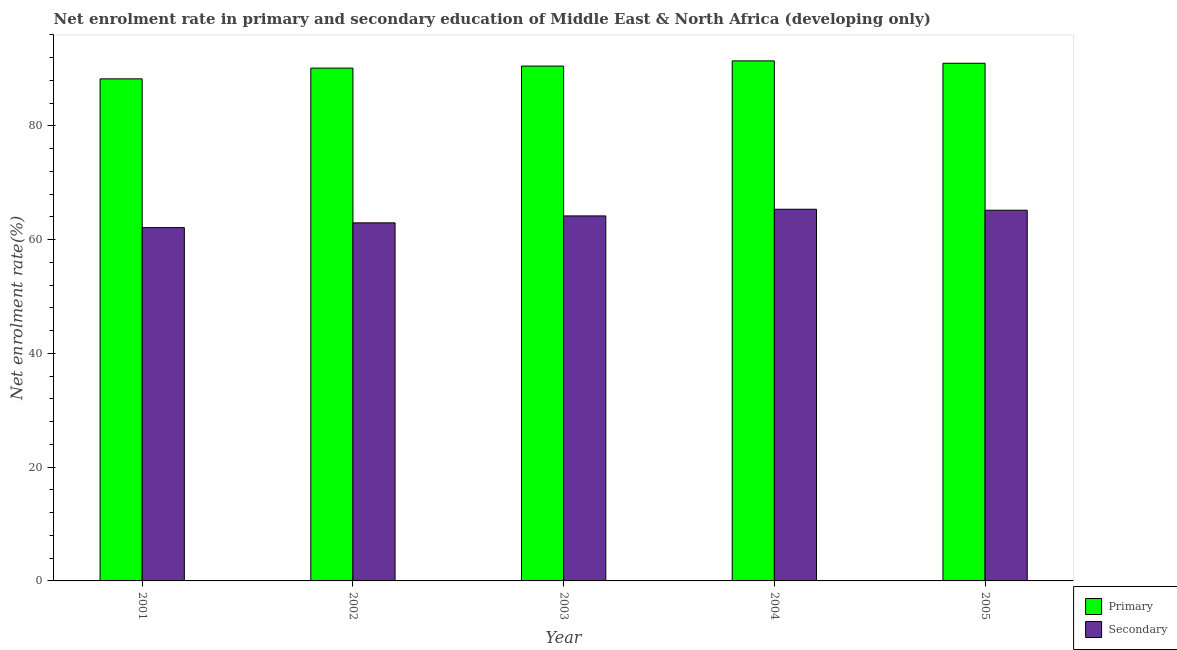How many different coloured bars are there?
Provide a succinct answer. 2. How many groups of bars are there?
Keep it short and to the point. 5. Are the number of bars on each tick of the X-axis equal?
Offer a terse response. Yes. How many bars are there on the 3rd tick from the left?
Make the answer very short. 2. What is the label of the 4th group of bars from the left?
Offer a terse response. 2004. In how many cases, is the number of bars for a given year not equal to the number of legend labels?
Your answer should be compact. 0. What is the enrollment rate in primary education in 2004?
Offer a very short reply. 91.43. Across all years, what is the maximum enrollment rate in primary education?
Offer a terse response. 91.43. Across all years, what is the minimum enrollment rate in primary education?
Give a very brief answer. 88.27. What is the total enrollment rate in primary education in the graph?
Your answer should be very brief. 451.39. What is the difference between the enrollment rate in primary education in 2001 and that in 2003?
Ensure brevity in your answer.  -2.25. What is the difference between the enrollment rate in secondary education in 2005 and the enrollment rate in primary education in 2001?
Provide a succinct answer. 3.05. What is the average enrollment rate in secondary education per year?
Your answer should be compact. 63.95. What is the ratio of the enrollment rate in secondary education in 2001 to that in 2004?
Keep it short and to the point. 0.95. What is the difference between the highest and the second highest enrollment rate in secondary education?
Give a very brief answer. 0.17. What is the difference between the highest and the lowest enrollment rate in secondary education?
Offer a very short reply. 3.22. Is the sum of the enrollment rate in secondary education in 2004 and 2005 greater than the maximum enrollment rate in primary education across all years?
Give a very brief answer. Yes. What does the 2nd bar from the left in 2003 represents?
Ensure brevity in your answer.  Secondary. What does the 2nd bar from the right in 2001 represents?
Your response must be concise. Primary. How many years are there in the graph?
Ensure brevity in your answer.  5. What is the difference between two consecutive major ticks on the Y-axis?
Offer a very short reply. 20. Are the values on the major ticks of Y-axis written in scientific E-notation?
Your response must be concise. No. Where does the legend appear in the graph?
Provide a succinct answer. Bottom right. What is the title of the graph?
Your response must be concise. Net enrolment rate in primary and secondary education of Middle East & North Africa (developing only). What is the label or title of the Y-axis?
Your answer should be very brief. Net enrolment rate(%). What is the Net enrolment rate(%) in Primary in 2001?
Ensure brevity in your answer.  88.27. What is the Net enrolment rate(%) in Secondary in 2001?
Offer a terse response. 62.12. What is the Net enrolment rate(%) of Primary in 2002?
Keep it short and to the point. 90.16. What is the Net enrolment rate(%) in Secondary in 2002?
Provide a succinct answer. 62.95. What is the Net enrolment rate(%) in Primary in 2003?
Provide a succinct answer. 90.52. What is the Net enrolment rate(%) of Secondary in 2003?
Ensure brevity in your answer.  64.17. What is the Net enrolment rate(%) in Primary in 2004?
Offer a very short reply. 91.43. What is the Net enrolment rate(%) of Secondary in 2004?
Your answer should be compact. 65.34. What is the Net enrolment rate(%) of Primary in 2005?
Your answer should be very brief. 91.01. What is the Net enrolment rate(%) in Secondary in 2005?
Make the answer very short. 65.17. Across all years, what is the maximum Net enrolment rate(%) in Primary?
Your answer should be compact. 91.43. Across all years, what is the maximum Net enrolment rate(%) in Secondary?
Keep it short and to the point. 65.34. Across all years, what is the minimum Net enrolment rate(%) in Primary?
Offer a terse response. 88.27. Across all years, what is the minimum Net enrolment rate(%) of Secondary?
Provide a short and direct response. 62.12. What is the total Net enrolment rate(%) of Primary in the graph?
Your answer should be compact. 451.39. What is the total Net enrolment rate(%) in Secondary in the graph?
Keep it short and to the point. 319.76. What is the difference between the Net enrolment rate(%) of Primary in 2001 and that in 2002?
Give a very brief answer. -1.89. What is the difference between the Net enrolment rate(%) of Secondary in 2001 and that in 2002?
Give a very brief answer. -0.83. What is the difference between the Net enrolment rate(%) of Primary in 2001 and that in 2003?
Make the answer very short. -2.25. What is the difference between the Net enrolment rate(%) of Secondary in 2001 and that in 2003?
Make the answer very short. -2.05. What is the difference between the Net enrolment rate(%) in Primary in 2001 and that in 2004?
Keep it short and to the point. -3.16. What is the difference between the Net enrolment rate(%) in Secondary in 2001 and that in 2004?
Keep it short and to the point. -3.22. What is the difference between the Net enrolment rate(%) in Primary in 2001 and that in 2005?
Offer a terse response. -2.74. What is the difference between the Net enrolment rate(%) of Secondary in 2001 and that in 2005?
Your answer should be very brief. -3.05. What is the difference between the Net enrolment rate(%) of Primary in 2002 and that in 2003?
Make the answer very short. -0.36. What is the difference between the Net enrolment rate(%) of Secondary in 2002 and that in 2003?
Your answer should be very brief. -1.22. What is the difference between the Net enrolment rate(%) of Primary in 2002 and that in 2004?
Your answer should be very brief. -1.27. What is the difference between the Net enrolment rate(%) in Secondary in 2002 and that in 2004?
Offer a very short reply. -2.39. What is the difference between the Net enrolment rate(%) in Primary in 2002 and that in 2005?
Offer a terse response. -0.85. What is the difference between the Net enrolment rate(%) of Secondary in 2002 and that in 2005?
Offer a very short reply. -2.22. What is the difference between the Net enrolment rate(%) of Primary in 2003 and that in 2004?
Ensure brevity in your answer.  -0.91. What is the difference between the Net enrolment rate(%) of Secondary in 2003 and that in 2004?
Provide a short and direct response. -1.17. What is the difference between the Net enrolment rate(%) in Primary in 2003 and that in 2005?
Give a very brief answer. -0.49. What is the difference between the Net enrolment rate(%) in Secondary in 2003 and that in 2005?
Give a very brief answer. -1. What is the difference between the Net enrolment rate(%) in Primary in 2004 and that in 2005?
Keep it short and to the point. 0.42. What is the difference between the Net enrolment rate(%) of Secondary in 2004 and that in 2005?
Make the answer very short. 0.17. What is the difference between the Net enrolment rate(%) in Primary in 2001 and the Net enrolment rate(%) in Secondary in 2002?
Your answer should be very brief. 25.32. What is the difference between the Net enrolment rate(%) in Primary in 2001 and the Net enrolment rate(%) in Secondary in 2003?
Give a very brief answer. 24.1. What is the difference between the Net enrolment rate(%) of Primary in 2001 and the Net enrolment rate(%) of Secondary in 2004?
Offer a very short reply. 22.93. What is the difference between the Net enrolment rate(%) in Primary in 2001 and the Net enrolment rate(%) in Secondary in 2005?
Your answer should be compact. 23.1. What is the difference between the Net enrolment rate(%) of Primary in 2002 and the Net enrolment rate(%) of Secondary in 2003?
Make the answer very short. 25.99. What is the difference between the Net enrolment rate(%) of Primary in 2002 and the Net enrolment rate(%) of Secondary in 2004?
Provide a short and direct response. 24.82. What is the difference between the Net enrolment rate(%) in Primary in 2002 and the Net enrolment rate(%) in Secondary in 2005?
Offer a very short reply. 24.99. What is the difference between the Net enrolment rate(%) of Primary in 2003 and the Net enrolment rate(%) of Secondary in 2004?
Make the answer very short. 25.17. What is the difference between the Net enrolment rate(%) of Primary in 2003 and the Net enrolment rate(%) of Secondary in 2005?
Give a very brief answer. 25.35. What is the difference between the Net enrolment rate(%) of Primary in 2004 and the Net enrolment rate(%) of Secondary in 2005?
Your answer should be compact. 26.26. What is the average Net enrolment rate(%) in Primary per year?
Ensure brevity in your answer.  90.28. What is the average Net enrolment rate(%) in Secondary per year?
Your response must be concise. 63.95. In the year 2001, what is the difference between the Net enrolment rate(%) of Primary and Net enrolment rate(%) of Secondary?
Your answer should be very brief. 26.15. In the year 2002, what is the difference between the Net enrolment rate(%) in Primary and Net enrolment rate(%) in Secondary?
Provide a short and direct response. 27.21. In the year 2003, what is the difference between the Net enrolment rate(%) in Primary and Net enrolment rate(%) in Secondary?
Ensure brevity in your answer.  26.35. In the year 2004, what is the difference between the Net enrolment rate(%) in Primary and Net enrolment rate(%) in Secondary?
Your answer should be very brief. 26.09. In the year 2005, what is the difference between the Net enrolment rate(%) in Primary and Net enrolment rate(%) in Secondary?
Ensure brevity in your answer.  25.84. What is the ratio of the Net enrolment rate(%) of Primary in 2001 to that in 2002?
Provide a succinct answer. 0.98. What is the ratio of the Net enrolment rate(%) in Secondary in 2001 to that in 2002?
Offer a very short reply. 0.99. What is the ratio of the Net enrolment rate(%) in Primary in 2001 to that in 2003?
Your answer should be compact. 0.98. What is the ratio of the Net enrolment rate(%) in Secondary in 2001 to that in 2003?
Provide a short and direct response. 0.97. What is the ratio of the Net enrolment rate(%) in Primary in 2001 to that in 2004?
Your answer should be compact. 0.97. What is the ratio of the Net enrolment rate(%) of Secondary in 2001 to that in 2004?
Your response must be concise. 0.95. What is the ratio of the Net enrolment rate(%) of Primary in 2001 to that in 2005?
Give a very brief answer. 0.97. What is the ratio of the Net enrolment rate(%) in Secondary in 2001 to that in 2005?
Give a very brief answer. 0.95. What is the ratio of the Net enrolment rate(%) of Primary in 2002 to that in 2004?
Keep it short and to the point. 0.99. What is the ratio of the Net enrolment rate(%) in Secondary in 2002 to that in 2004?
Offer a terse response. 0.96. What is the ratio of the Net enrolment rate(%) of Secondary in 2003 to that in 2004?
Provide a succinct answer. 0.98. What is the ratio of the Net enrolment rate(%) of Secondary in 2003 to that in 2005?
Offer a very short reply. 0.98. What is the ratio of the Net enrolment rate(%) in Primary in 2004 to that in 2005?
Your answer should be very brief. 1. What is the ratio of the Net enrolment rate(%) in Secondary in 2004 to that in 2005?
Keep it short and to the point. 1. What is the difference between the highest and the second highest Net enrolment rate(%) in Primary?
Provide a succinct answer. 0.42. What is the difference between the highest and the second highest Net enrolment rate(%) of Secondary?
Provide a succinct answer. 0.17. What is the difference between the highest and the lowest Net enrolment rate(%) in Primary?
Your answer should be compact. 3.16. What is the difference between the highest and the lowest Net enrolment rate(%) in Secondary?
Provide a short and direct response. 3.22. 